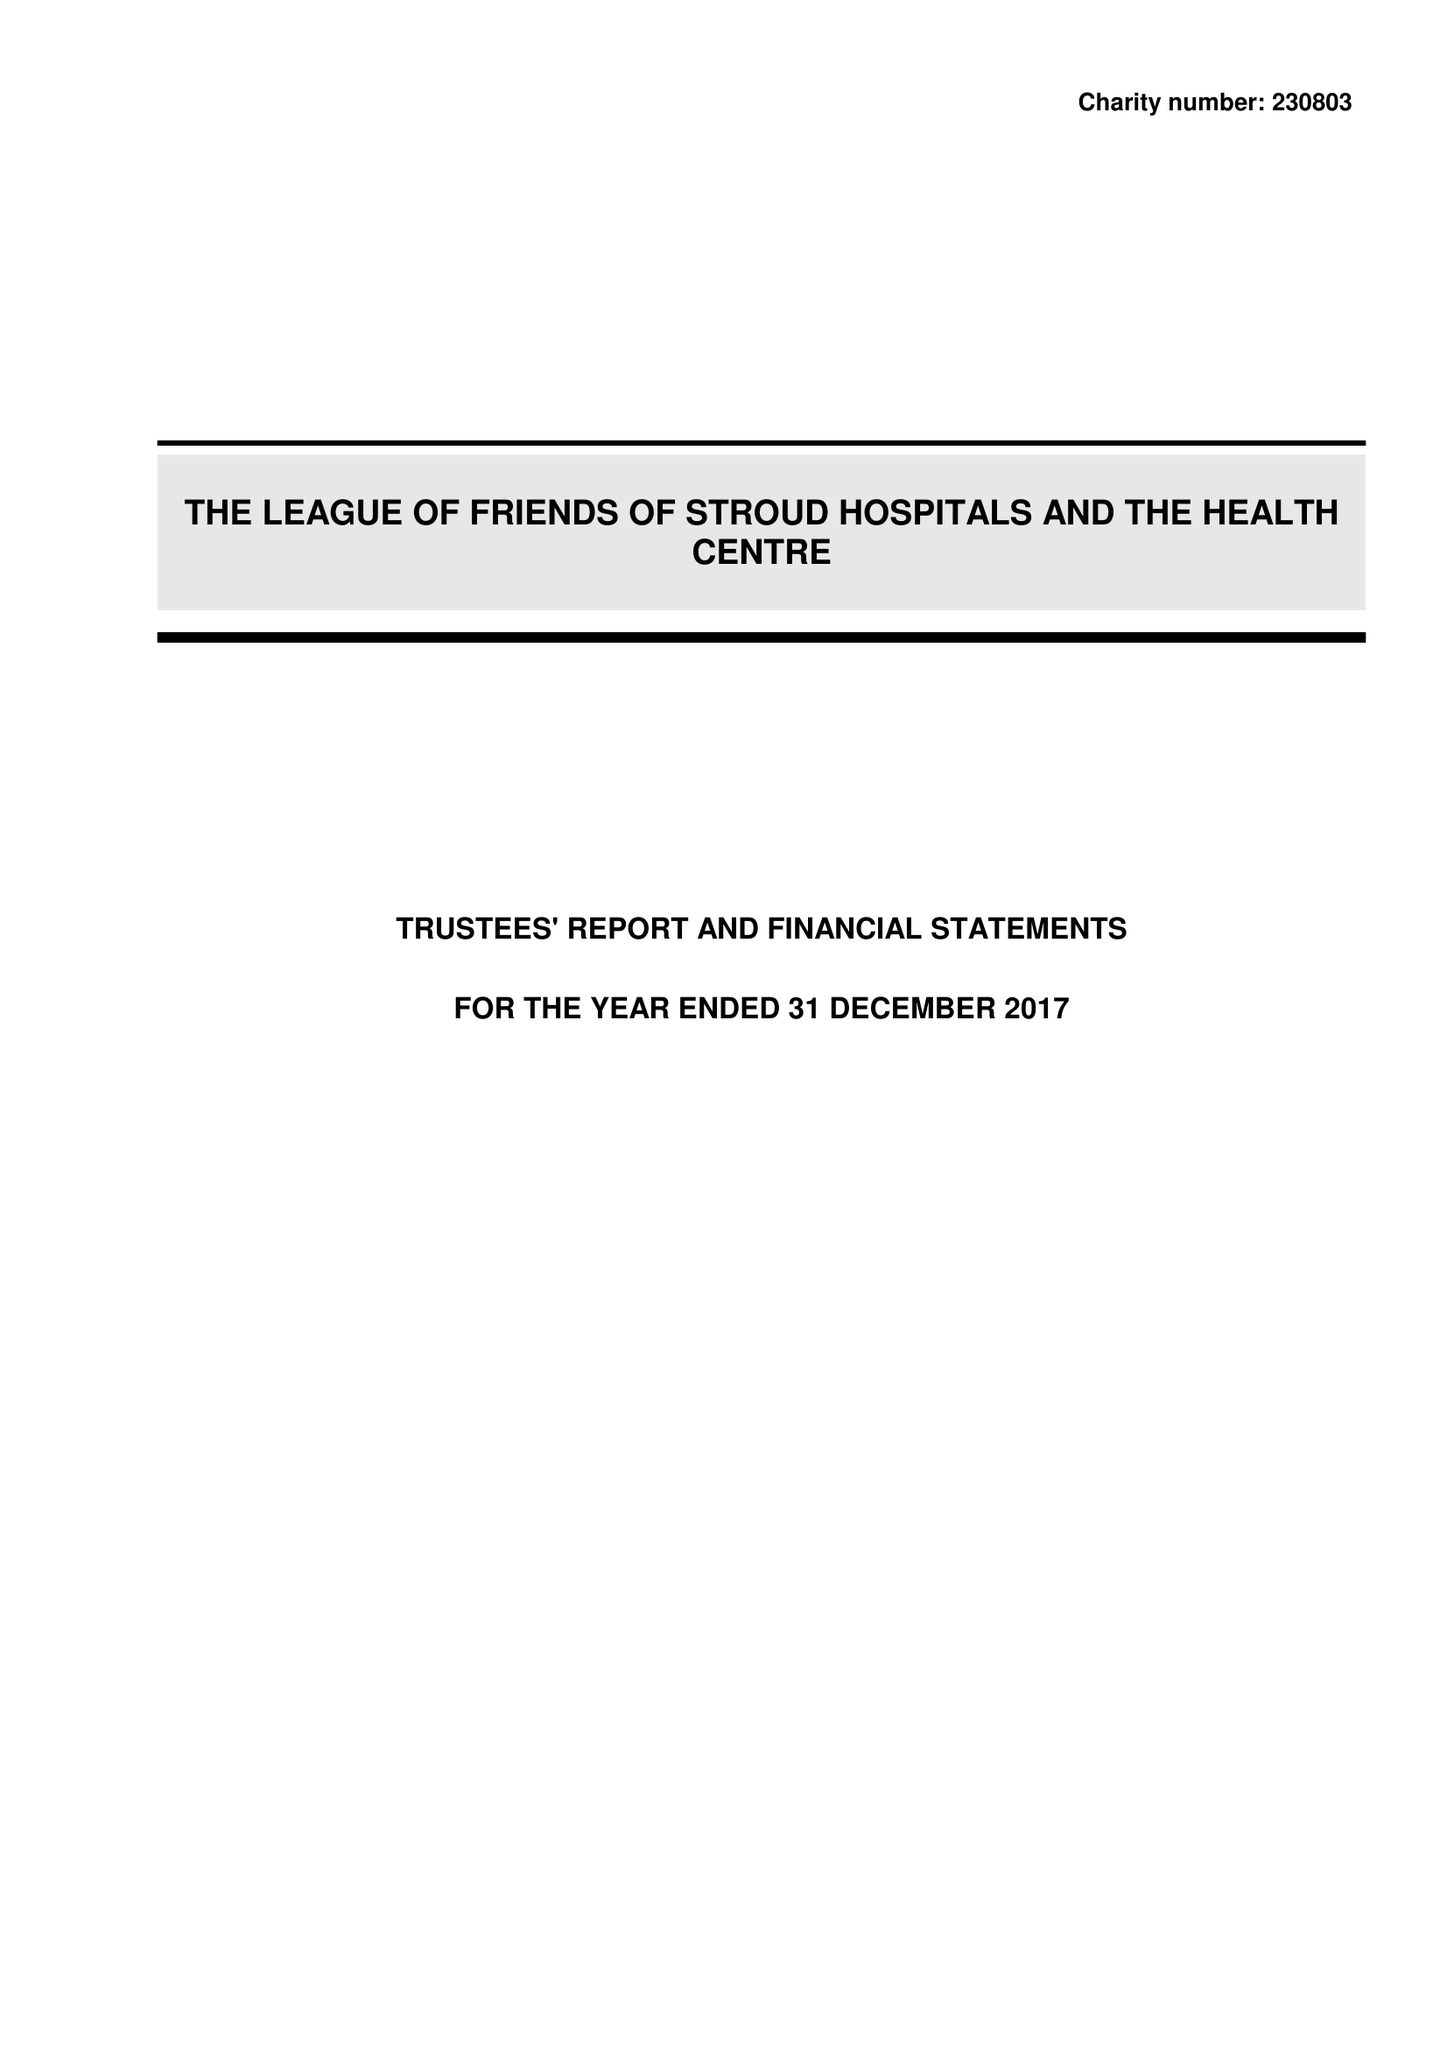What is the value for the spending_annually_in_british_pounds?
Answer the question using a single word or phrase. 139334.00 